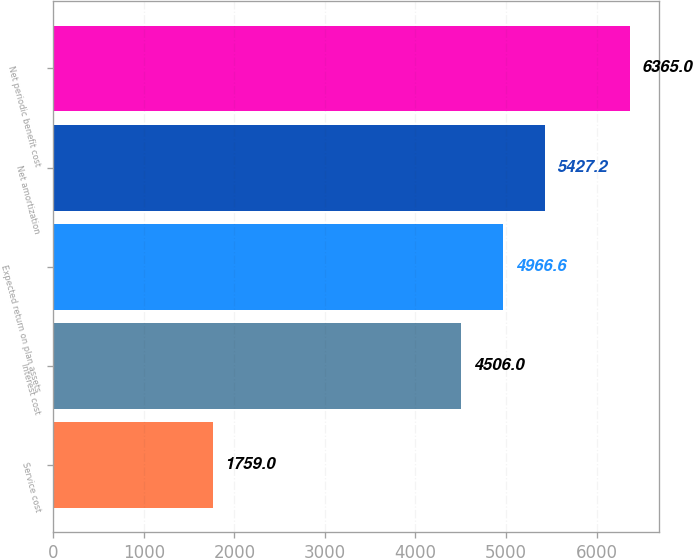Convert chart. <chart><loc_0><loc_0><loc_500><loc_500><bar_chart><fcel>Service cost<fcel>Interest cost<fcel>Expected return on plan assets<fcel>Net amortization<fcel>Net periodic benefit cost<nl><fcel>1759<fcel>4506<fcel>4966.6<fcel>5427.2<fcel>6365<nl></chart> 